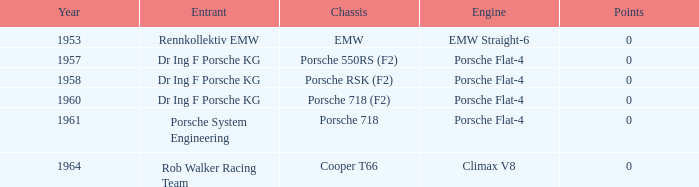Which year had more than 0 points? 0.0. 